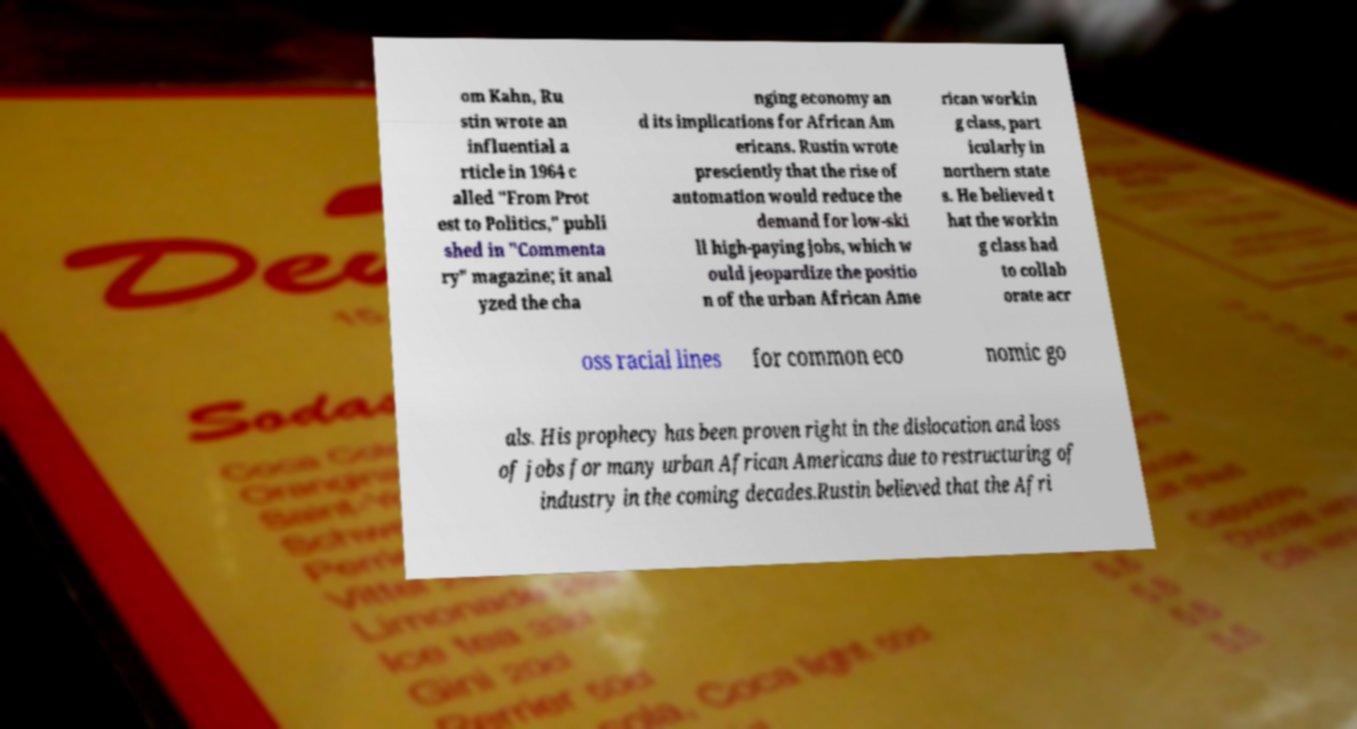I need the written content from this picture converted into text. Can you do that? om Kahn, Ru stin wrote an influential a rticle in 1964 c alled "From Prot est to Politics," publi shed in "Commenta ry" magazine; it anal yzed the cha nging economy an d its implications for African Am ericans. Rustin wrote presciently that the rise of automation would reduce the demand for low-ski ll high-paying jobs, which w ould jeopardize the positio n of the urban African Ame rican workin g class, part icularly in northern state s. He believed t hat the workin g class had to collab orate acr oss racial lines for common eco nomic go als. His prophecy has been proven right in the dislocation and loss of jobs for many urban African Americans due to restructuring of industry in the coming decades.Rustin believed that the Afri 